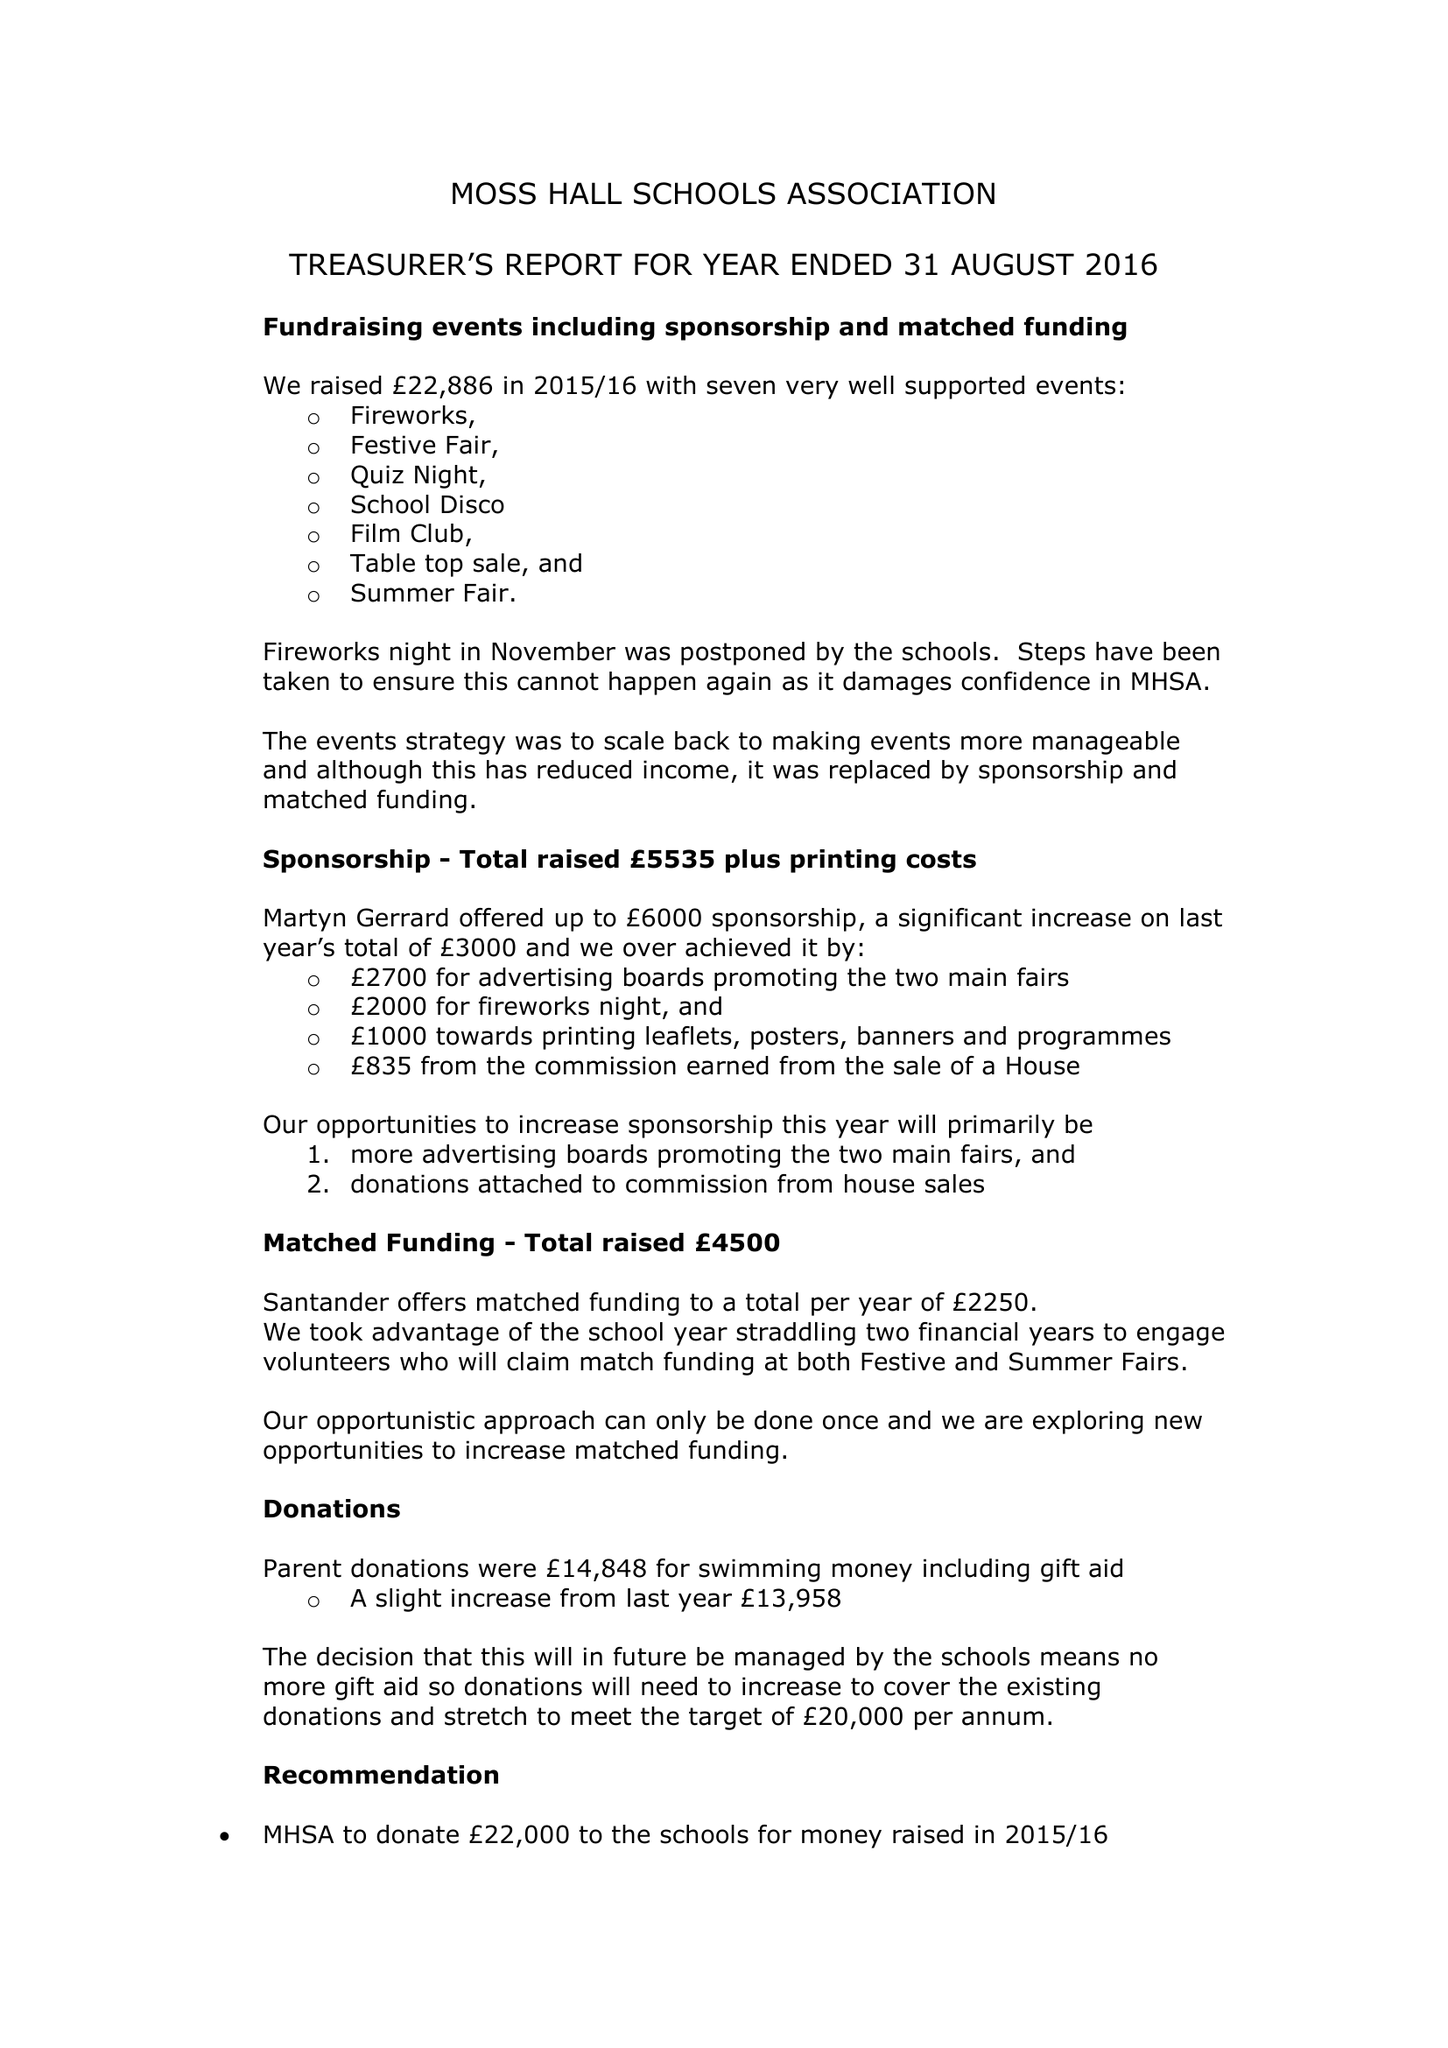What is the value for the income_annually_in_british_pounds?
Answer the question using a single word or phrase. 33260.00 